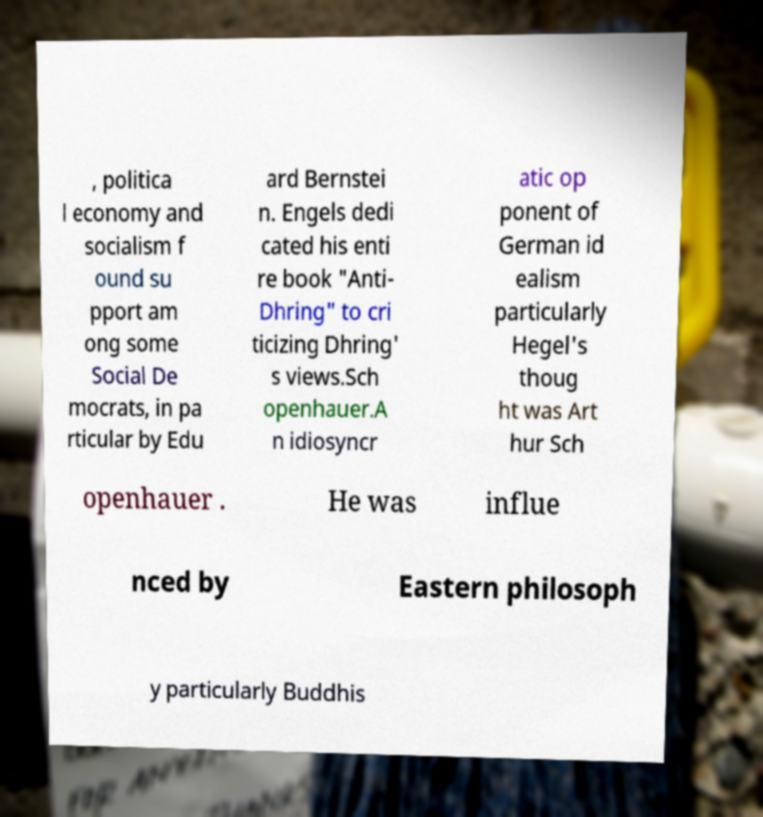What messages or text are displayed in this image? I need them in a readable, typed format. , politica l economy and socialism f ound su pport am ong some Social De mocrats, in pa rticular by Edu ard Bernstei n. Engels dedi cated his enti re book "Anti- Dhring" to cri ticizing Dhring' s views.Sch openhauer.A n idiosyncr atic op ponent of German id ealism particularly Hegel's thoug ht was Art hur Sch openhauer . He was influe nced by Eastern philosoph y particularly Buddhis 